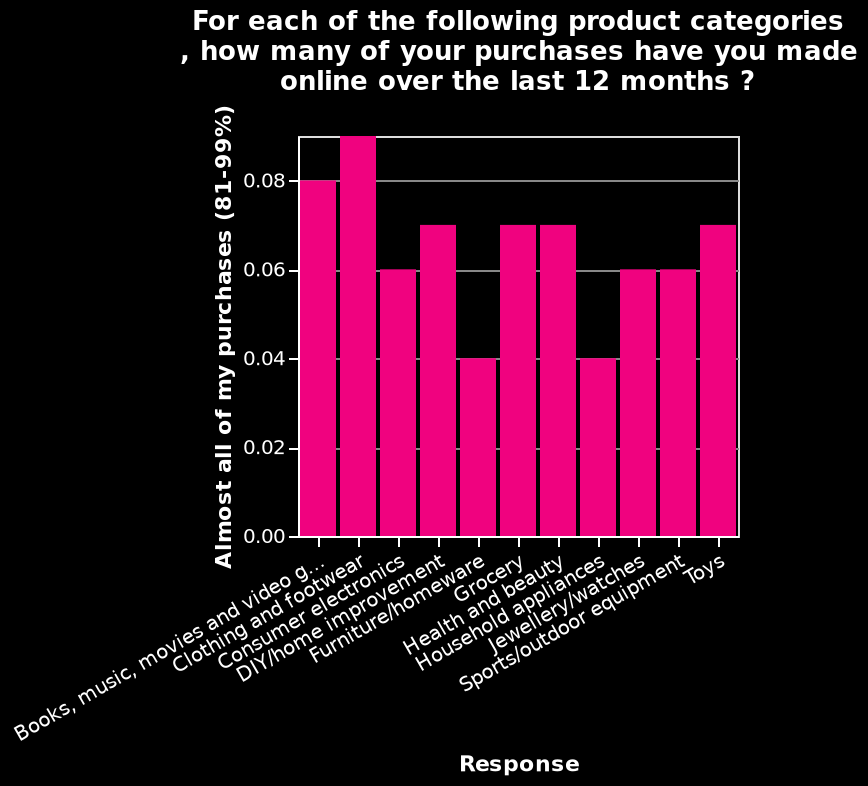<image>
please enumerates aspects of the construction of the chart This bar diagram is called For each of the following product categories , how many of your purchases have you made online over the last 12 months ?. The y-axis shows Almost all of my purchases (81-99%) while the x-axis measures Response. Offer a thorough analysis of the image. Clothing and footwear was the most purchased item online over the last 12 months, followed closely by books, music, movies and video games. The least purchased items online were furniture/homeware and household appliances. What does the x-axis measure in the bar diagram?  The x-axis measures the response of individuals in terms of their online purchases over the last 12 months. 